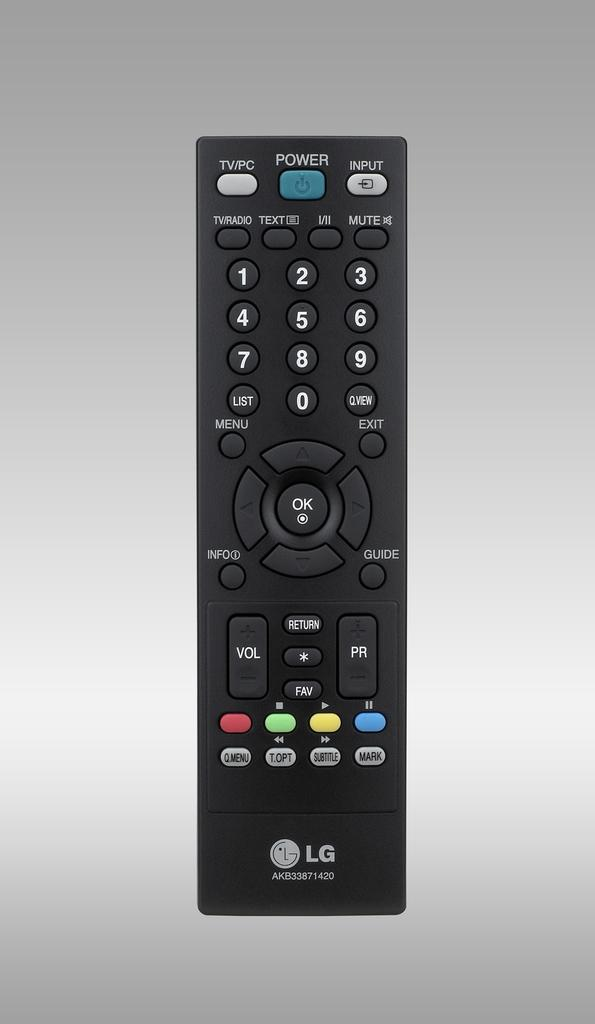<image>
Render a clear and concise summary of the photo. the remote control to an LG banded electronic device with a blue power button on the top. 